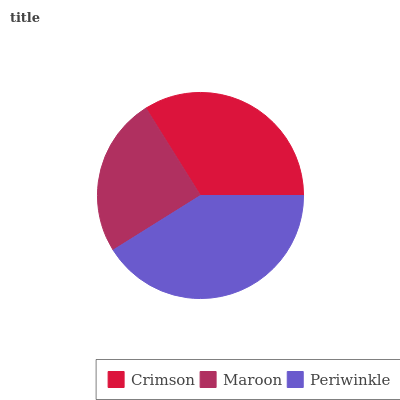Is Maroon the minimum?
Answer yes or no. Yes. Is Periwinkle the maximum?
Answer yes or no. Yes. Is Periwinkle the minimum?
Answer yes or no. No. Is Maroon the maximum?
Answer yes or no. No. Is Periwinkle greater than Maroon?
Answer yes or no. Yes. Is Maroon less than Periwinkle?
Answer yes or no. Yes. Is Maroon greater than Periwinkle?
Answer yes or no. No. Is Periwinkle less than Maroon?
Answer yes or no. No. Is Crimson the high median?
Answer yes or no. Yes. Is Crimson the low median?
Answer yes or no. Yes. Is Periwinkle the high median?
Answer yes or no. No. Is Maroon the low median?
Answer yes or no. No. 